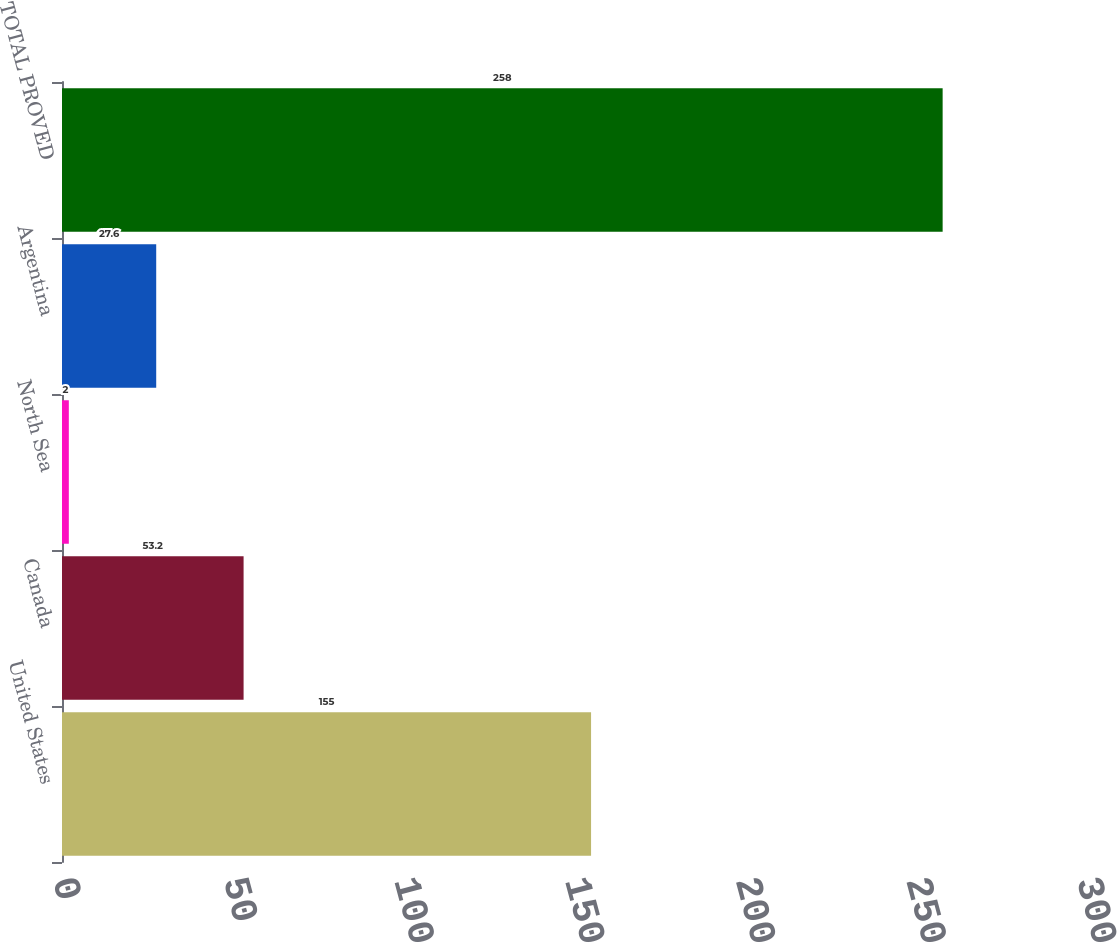Convert chart. <chart><loc_0><loc_0><loc_500><loc_500><bar_chart><fcel>United States<fcel>Canada<fcel>North Sea<fcel>Argentina<fcel>TOTAL PROVED<nl><fcel>155<fcel>53.2<fcel>2<fcel>27.6<fcel>258<nl></chart> 